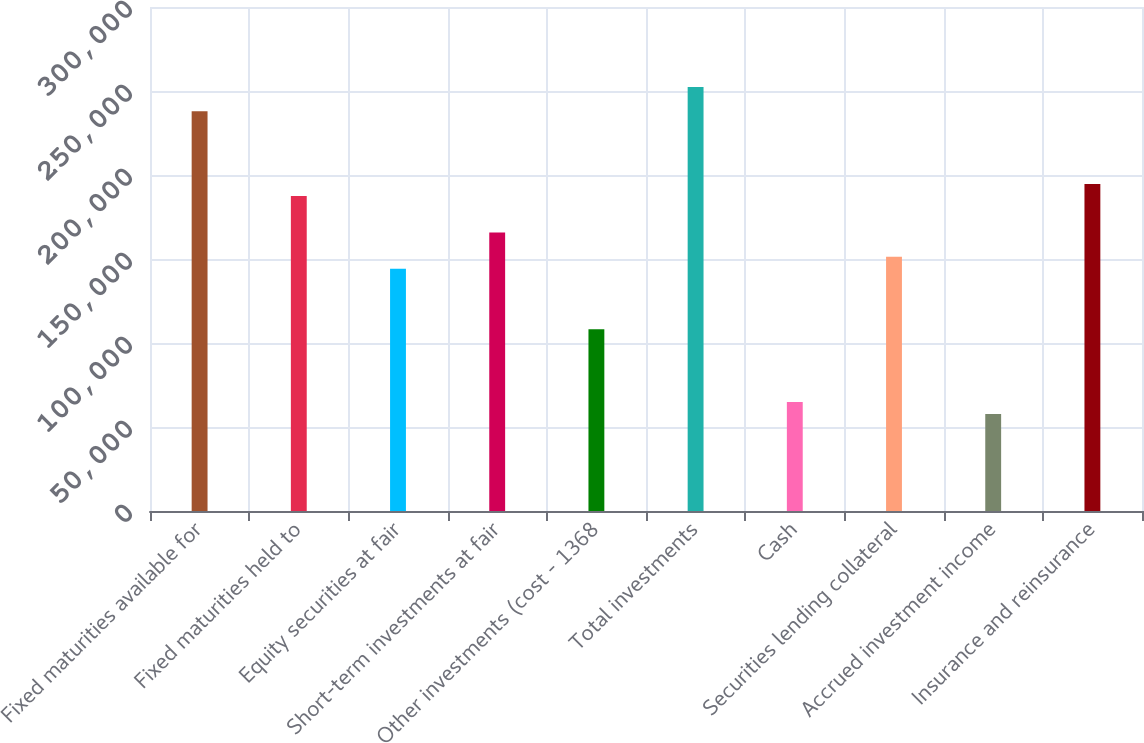Convert chart. <chart><loc_0><loc_0><loc_500><loc_500><bar_chart><fcel>Fixed maturities available for<fcel>Fixed maturities held to<fcel>Equity securities at fair<fcel>Short-term investments at fair<fcel>Other investments (cost - 1368<fcel>Total investments<fcel>Cash<fcel>Securities lending collateral<fcel>Accrued investment income<fcel>Insurance and reinsurance<nl><fcel>237890<fcel>187429<fcel>144177<fcel>165803<fcel>108134<fcel>252308<fcel>64881.3<fcel>151386<fcel>57672.6<fcel>194638<nl></chart> 